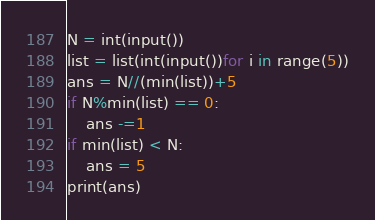<code> <loc_0><loc_0><loc_500><loc_500><_Python_>N = int(input())
list = list(int(input())for i in range(5))
ans = N//(min(list))+5
if N%min(list) == 0:
    ans -=1 
if min(list) < N:
    ans = 5
print(ans)</code> 